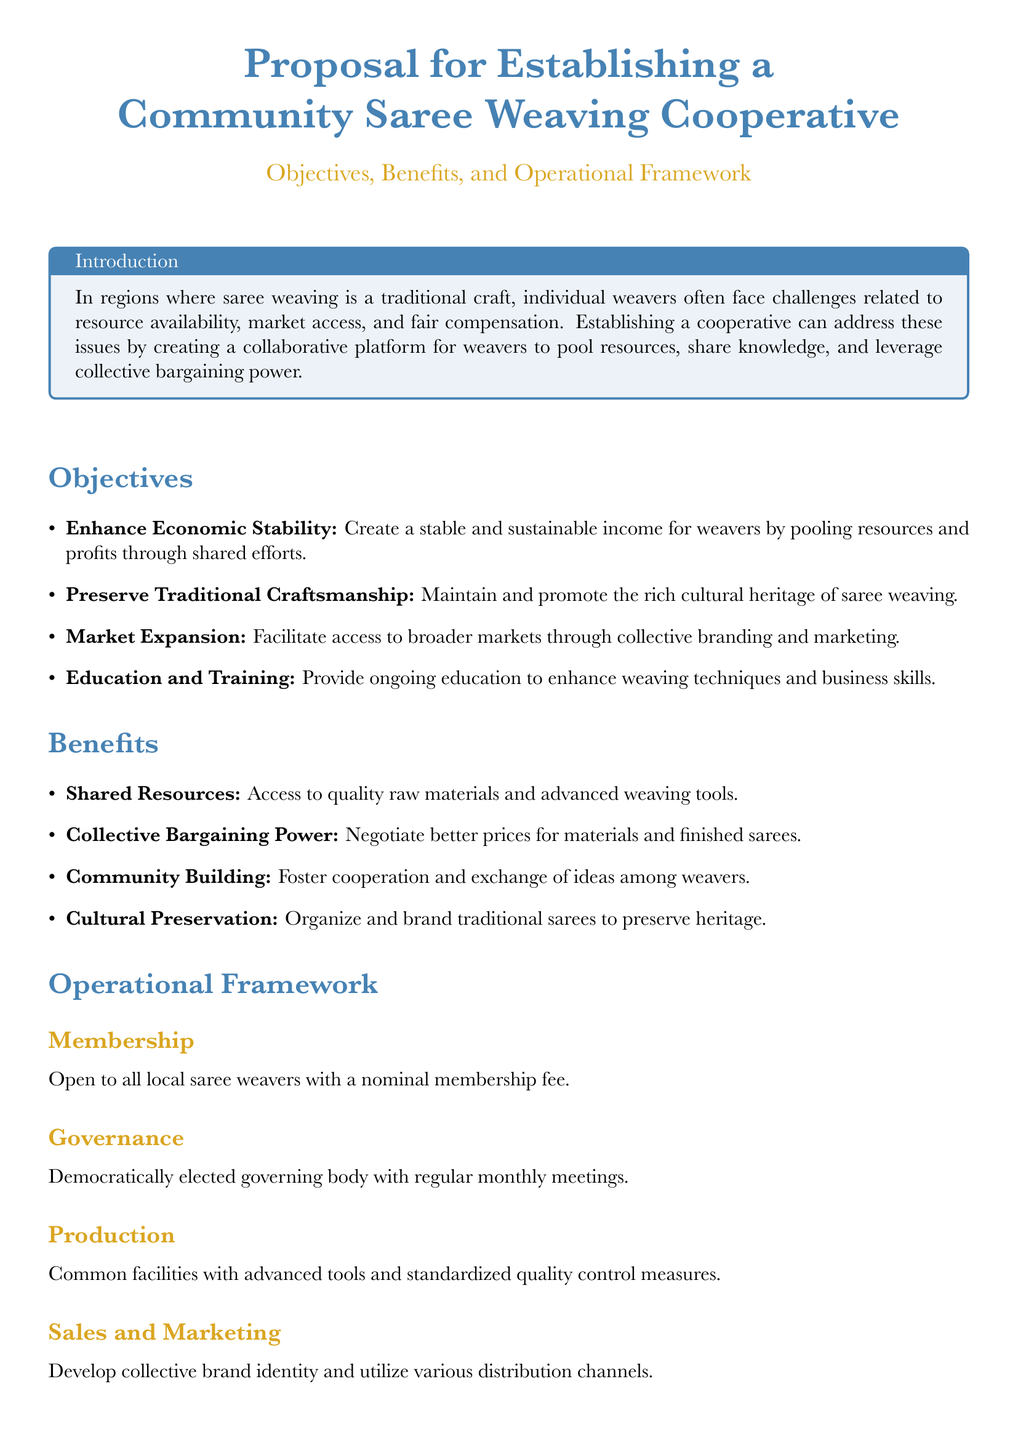What is the primary aim of the cooperative? The primary aim of the cooperative is to enhance economic stability for weavers.
Answer: Enhance Economic Stability How can the cooperative help in preserving traditional craftsmanship? The cooperative maintains and promotes the rich cultural heritage of saree weaving.
Answer: Preserve Traditional Craftsmanship What type of facilities will be provided for production? The document states that there will be common facilities with advanced tools.
Answer: Common facilities How frequently will the governing body meet? The governing body will have regular monthly meetings.
Answer: Monthly Who is eligible for membership in the cooperative? Membership is open to all local saree weavers.
Answer: All local saree weavers What is one of the benefits of collective bargaining? Collective bargaining allows negotiation for better prices for materials and finished sarees.
Answer: Better prices What form of financial management is mentioned? The financial management will involve initial funding through fees, grants, and equitable profit sharing.
Answer: Fees, grants, and equitable profit sharing What type of workshops will be conducted for sustainability? The cooperative will hold regular workshops on sustainable practices.
Answer: Sustainable practices What is the significance of collective branding and marketing? It facilitates access to broader markets for the weavers' products.
Answer: Access to broader markets 